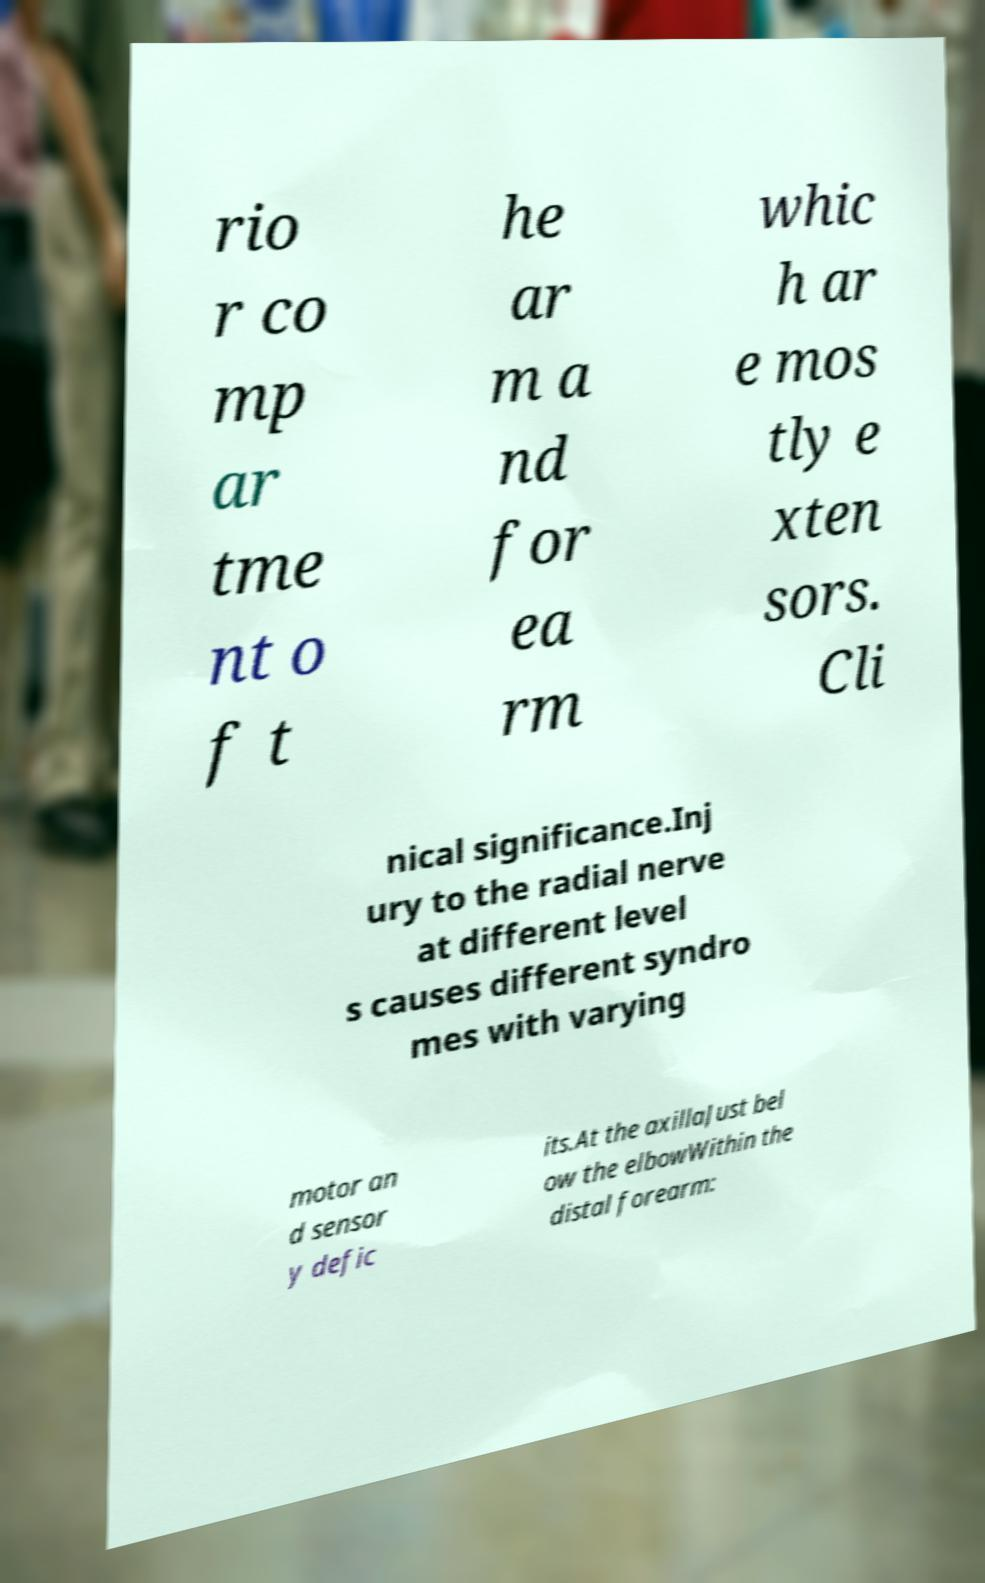Can you read and provide the text displayed in the image?This photo seems to have some interesting text. Can you extract and type it out for me? rio r co mp ar tme nt o f t he ar m a nd for ea rm whic h ar e mos tly e xten sors. Cli nical significance.Inj ury to the radial nerve at different level s causes different syndro mes with varying motor an d sensor y defic its.At the axillaJust bel ow the elbowWithin the distal forearm: 